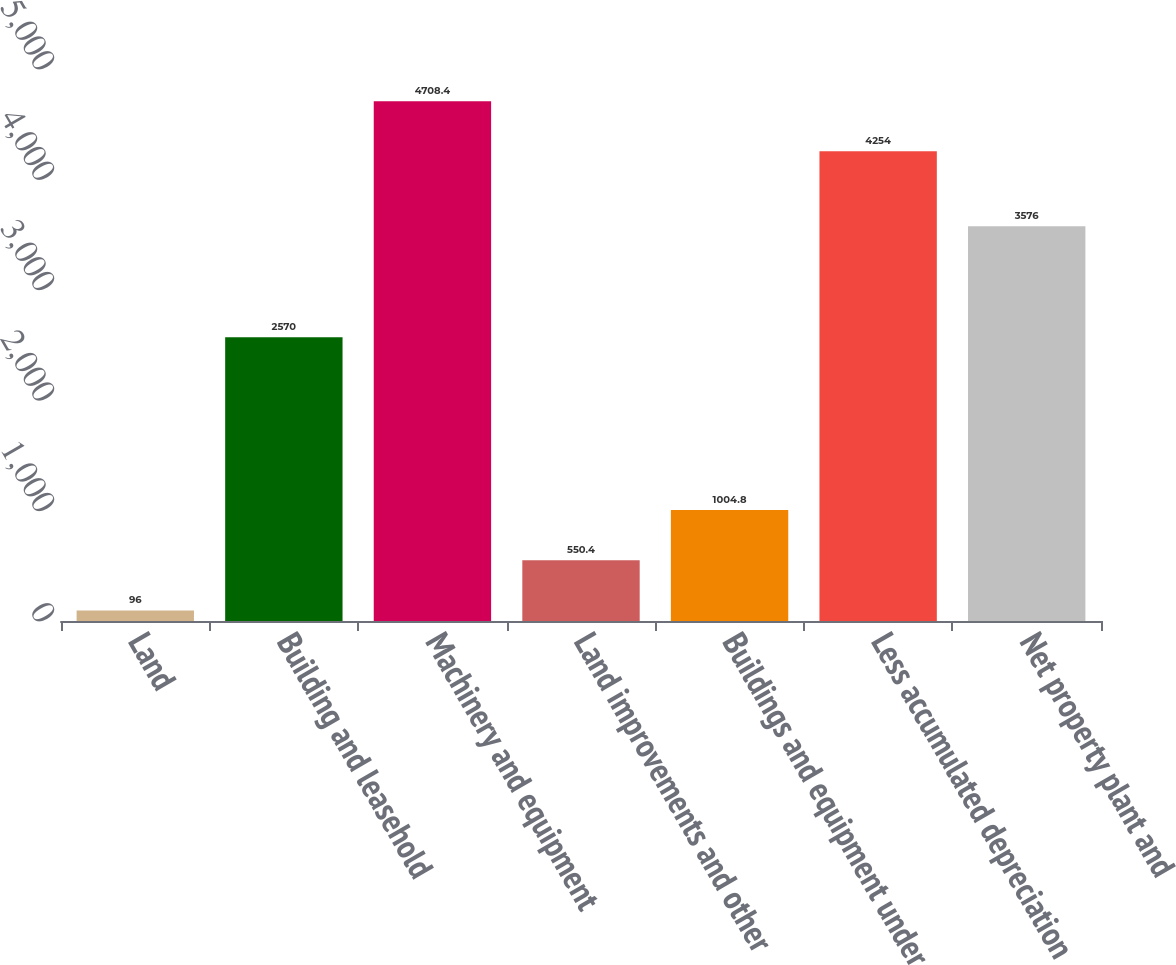Convert chart. <chart><loc_0><loc_0><loc_500><loc_500><bar_chart><fcel>Land<fcel>Building and leasehold<fcel>Machinery and equipment<fcel>Land improvements and other<fcel>Buildings and equipment under<fcel>Less accumulated depreciation<fcel>Net property plant and<nl><fcel>96<fcel>2570<fcel>4708.4<fcel>550.4<fcel>1004.8<fcel>4254<fcel>3576<nl></chart> 